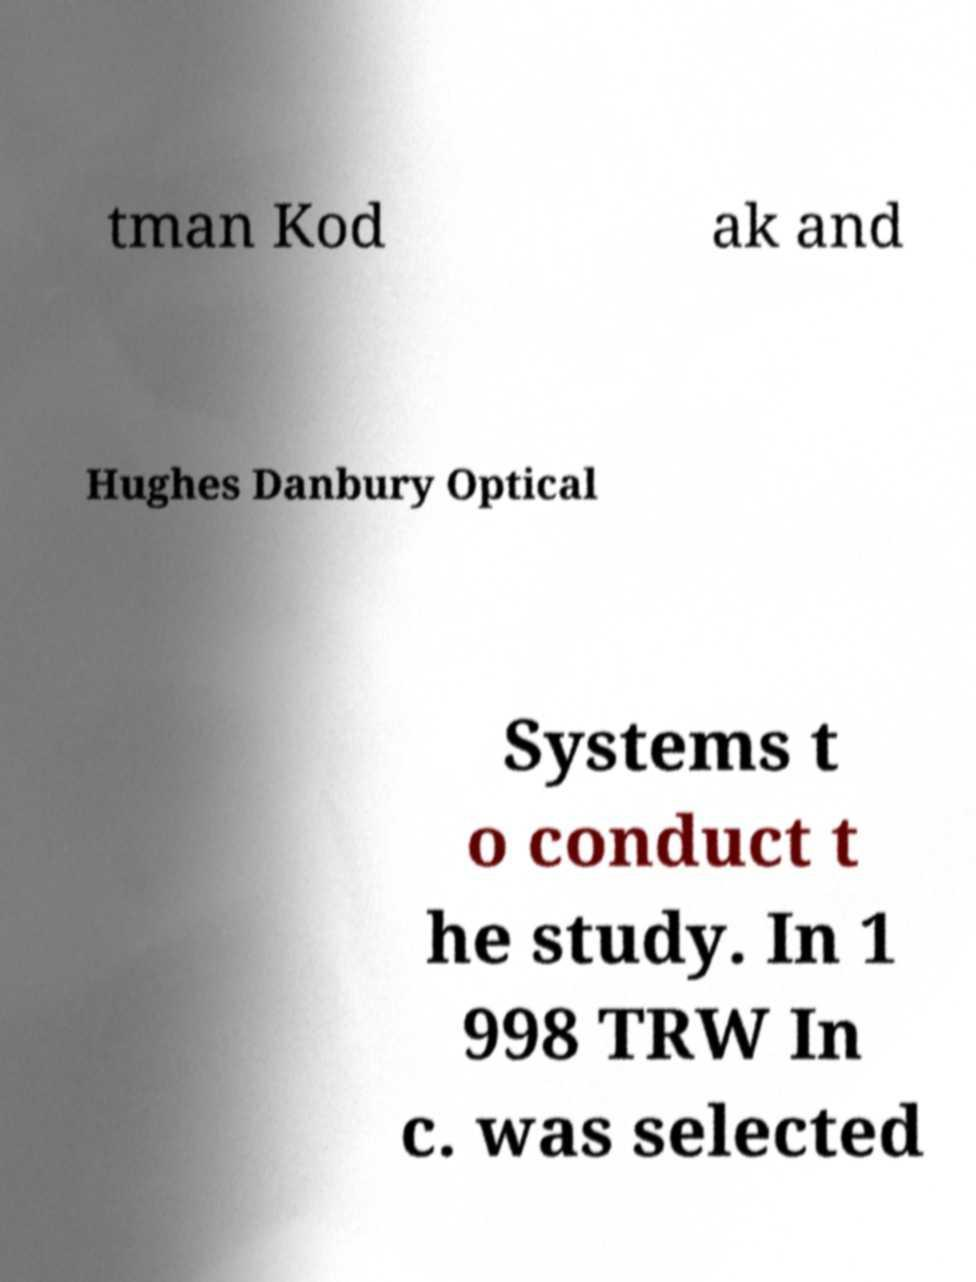There's text embedded in this image that I need extracted. Can you transcribe it verbatim? tman Kod ak and Hughes Danbury Optical Systems t o conduct t he study. In 1 998 TRW In c. was selected 